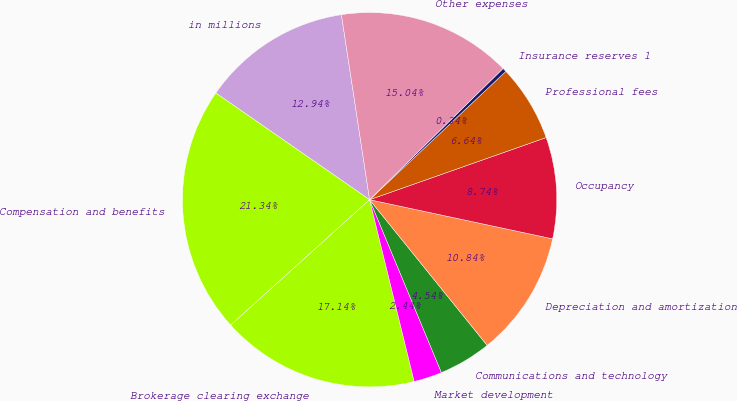<chart> <loc_0><loc_0><loc_500><loc_500><pie_chart><fcel>in millions<fcel>Compensation and benefits<fcel>Brokerage clearing exchange<fcel>Market development<fcel>Communications and technology<fcel>Depreciation and amortization<fcel>Occupancy<fcel>Professional fees<fcel>Insurance reserves 1<fcel>Other expenses<nl><fcel>12.94%<fcel>21.34%<fcel>17.14%<fcel>2.44%<fcel>4.54%<fcel>10.84%<fcel>8.74%<fcel>6.64%<fcel>0.34%<fcel>15.04%<nl></chart> 